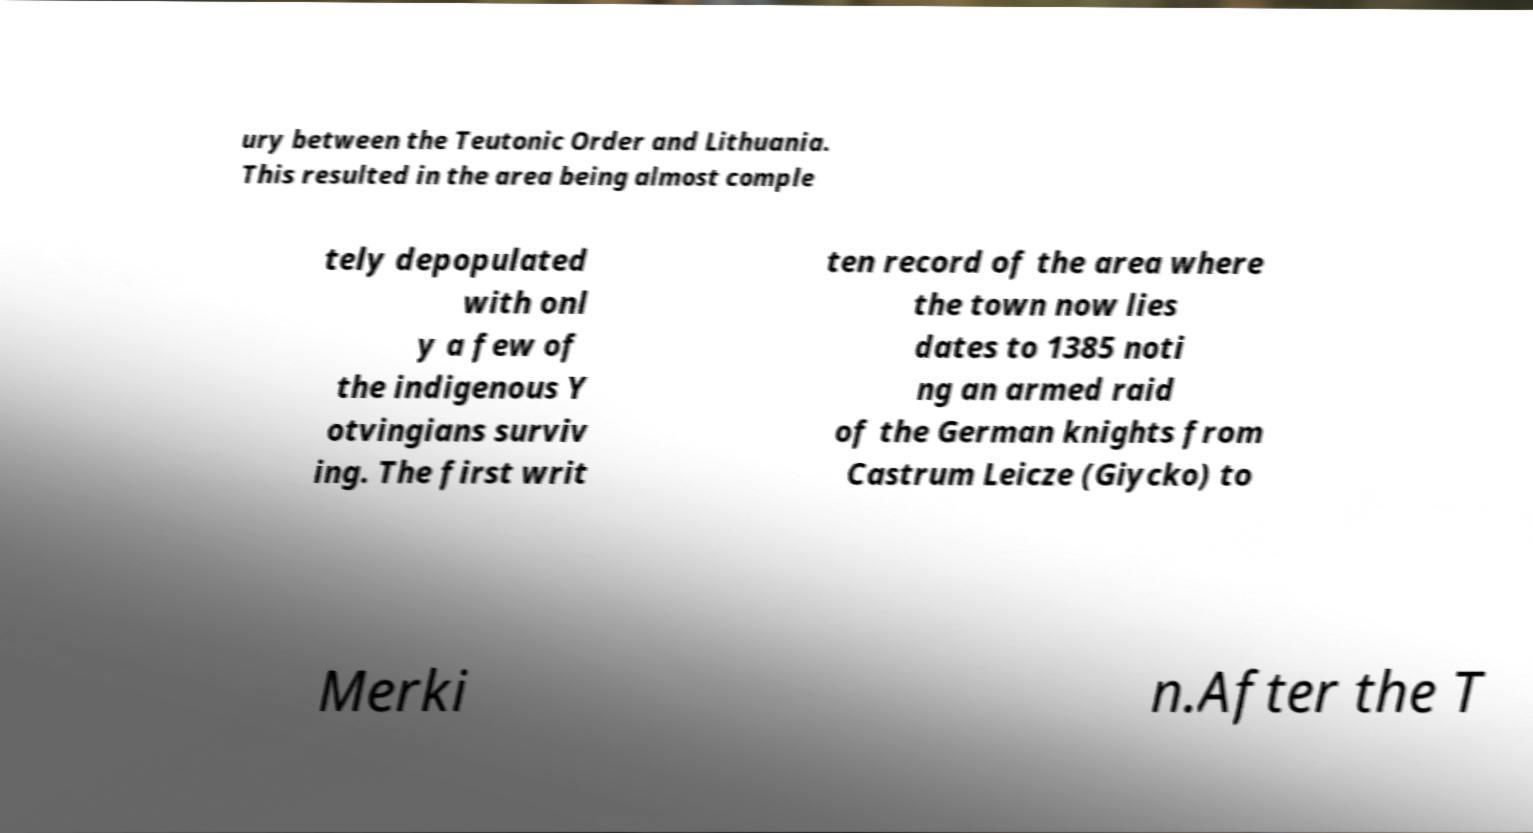Could you extract and type out the text from this image? ury between the Teutonic Order and Lithuania. This resulted in the area being almost comple tely depopulated with onl y a few of the indigenous Y otvingians surviv ing. The first writ ten record of the area where the town now lies dates to 1385 noti ng an armed raid of the German knights from Castrum Leicze (Giycko) to Merki n.After the T 